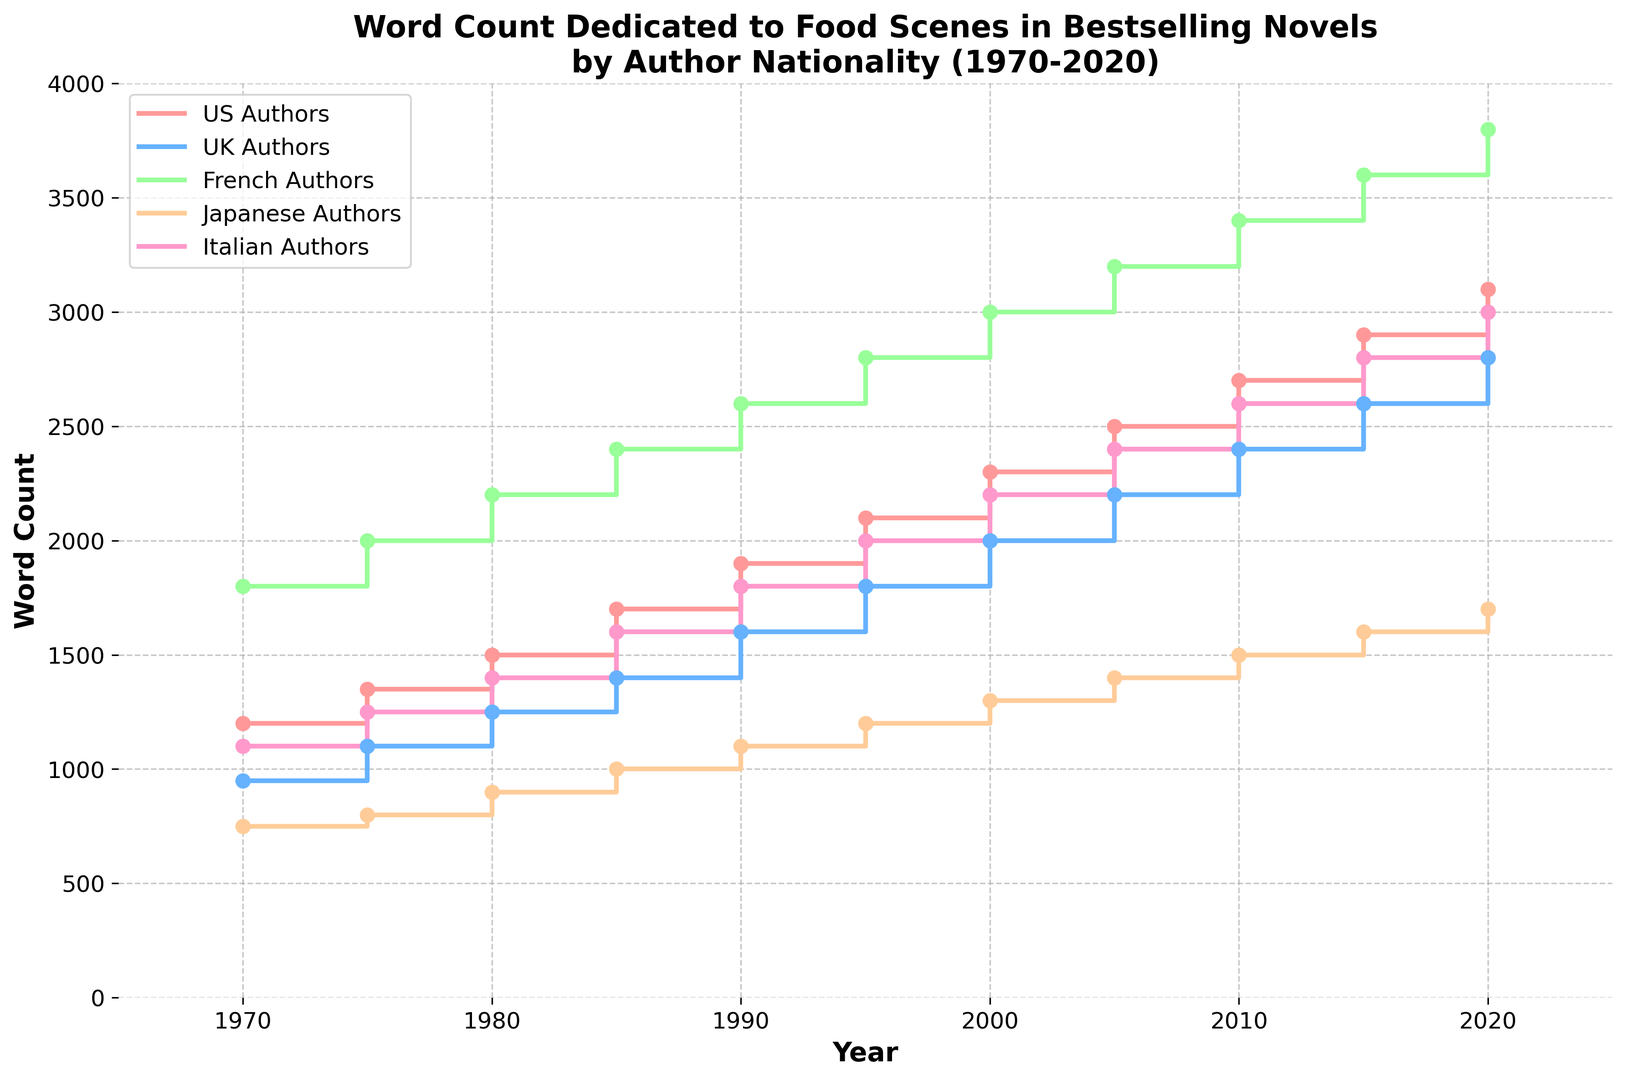How has the word count dedicated to food scenes in US Authors' novels changed from 1970 to 2020? From the plot, we can see that the word count for US Authors starts at 1200 in 1970 and increases steadily to 3100 in 2020. The increase can be calculated as 3100 - 1200.
Answer: The word count increased by 1900 words Which author nationality showed the highest increase in word count dedicated to food scenes over the 50-year period? We need to compare the increments for each nationality. US Authors: 3100 - 1200 = 1900; UK Authors: 2800 - 950 = 1850; French Authors: 3800 - 1800 = 2000; Japanese Authors: 1700 - 750 = 950; Italian Authors: 3000 - 1100 = 1900. French Authors showed the highest increase.
Answer: French Authors In which year did Italian Authors' word count exceed 2000 words? The plot shows that Italian Authors' word count exceeded 2000 words between 1995 and 2000.
Answer: 2000 In 1990, how did the word count for food scenes in French Authors' novels compare to that of UK Authors? In 1990, French Authors had 2600 words, while UK Authors had 1600 words. 2600 is greater than 1600, so the French Authors had more words.
Answer: French Authors had more words Which nationality had the lowest word count in 1975? By observing the word counts for 1975, we see US Authors: 1350; UK Authors: 1100; French Authors: 2000; Japanese Authors: 800; Italian Authors: 1250. Japanese Authors had the lowest word count.
Answer: Japanese Authors What is the average word count dedicated to food scenes for Japanese Authors between 1970 and 2020? First, sum the word counts: 750 + 800 + 900 + 1000 + 1100 + 1200 + 1300 + 1400 + 1500 + 1600 + 1700 = 14250. There are 11 data points, so the average is 14250 / 11.
Answer: 1295 Compare the increase in word count from 2000 to 2020 for US Authors and Italian Authors. Who had a greater increase? US Authors: 3100 - 2300 = 800; Italian Authors: 3000 - 2200 = 800. Both showed the same increase of 800 words.
Answer: Both the same What color represents UK Authors in the plot and what is their word count in 1985? The line for UK Authors is blue, and in 1985, the word count for UK Authors is 1400.
Answer: Blue; 1400 Did any author nationality have a constant word count increase every 5 years? By observing changes every 5 years for each nationality, French Authors show a consistent increase of 200 words every 5 years: 1800, 2000, 2200, 2400, 2600, 2800, 3000, 3200, 3400, 3600, 3800.
Answer: French Authors 